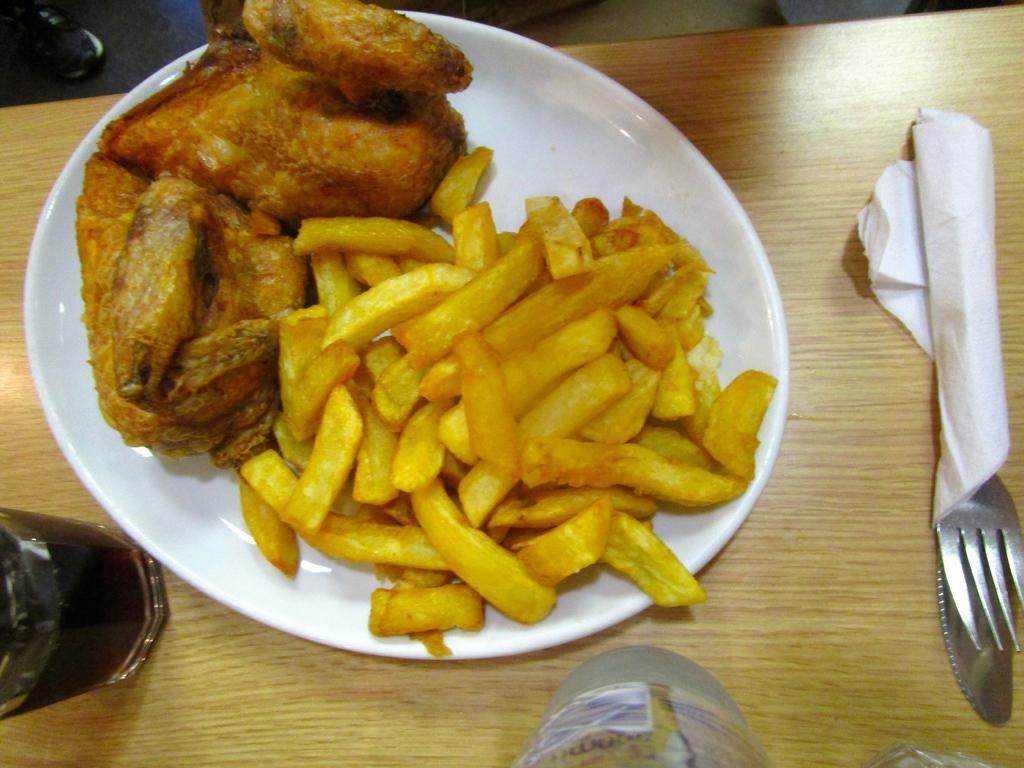Could you give a brief overview of what you see in this image? In this image we can see the food items present in the plate which is on the wooden table. We can also see the glass of drink, bottle and also the fork with a tissue. 